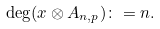Convert formula to latex. <formula><loc_0><loc_0><loc_500><loc_500>\deg ( x \otimes A _ { n , p } ) \colon = n .</formula> 